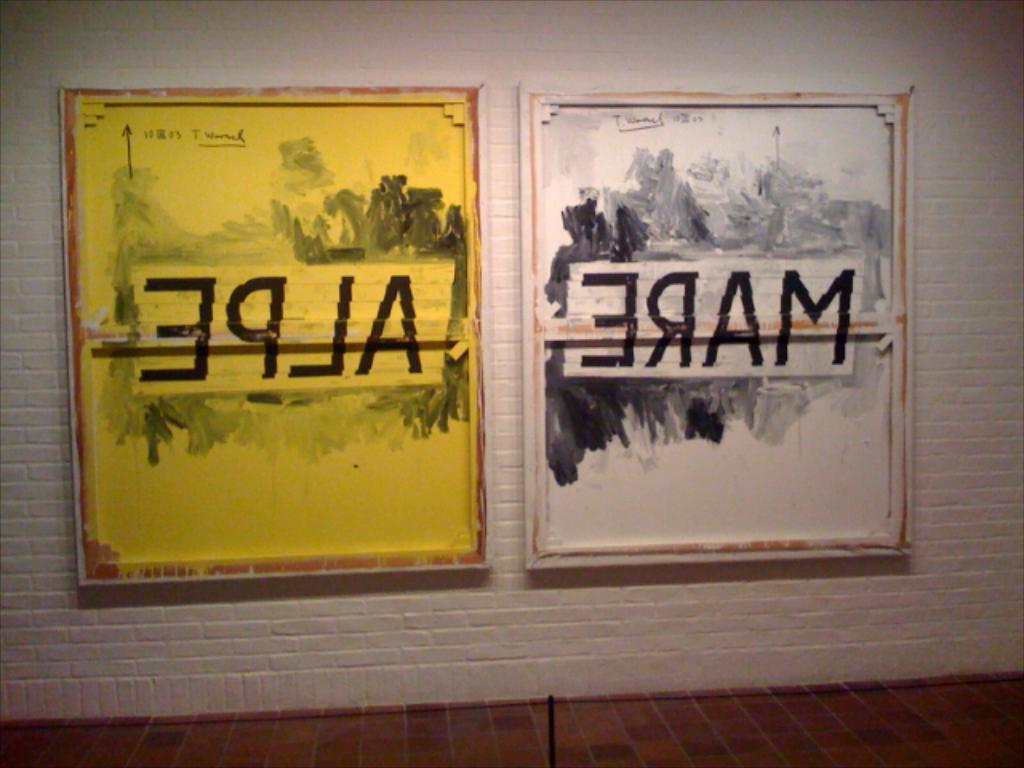<image>
Render a clear and concise summary of the photo. Two pictures hang on a wall with reverse writing on them. 